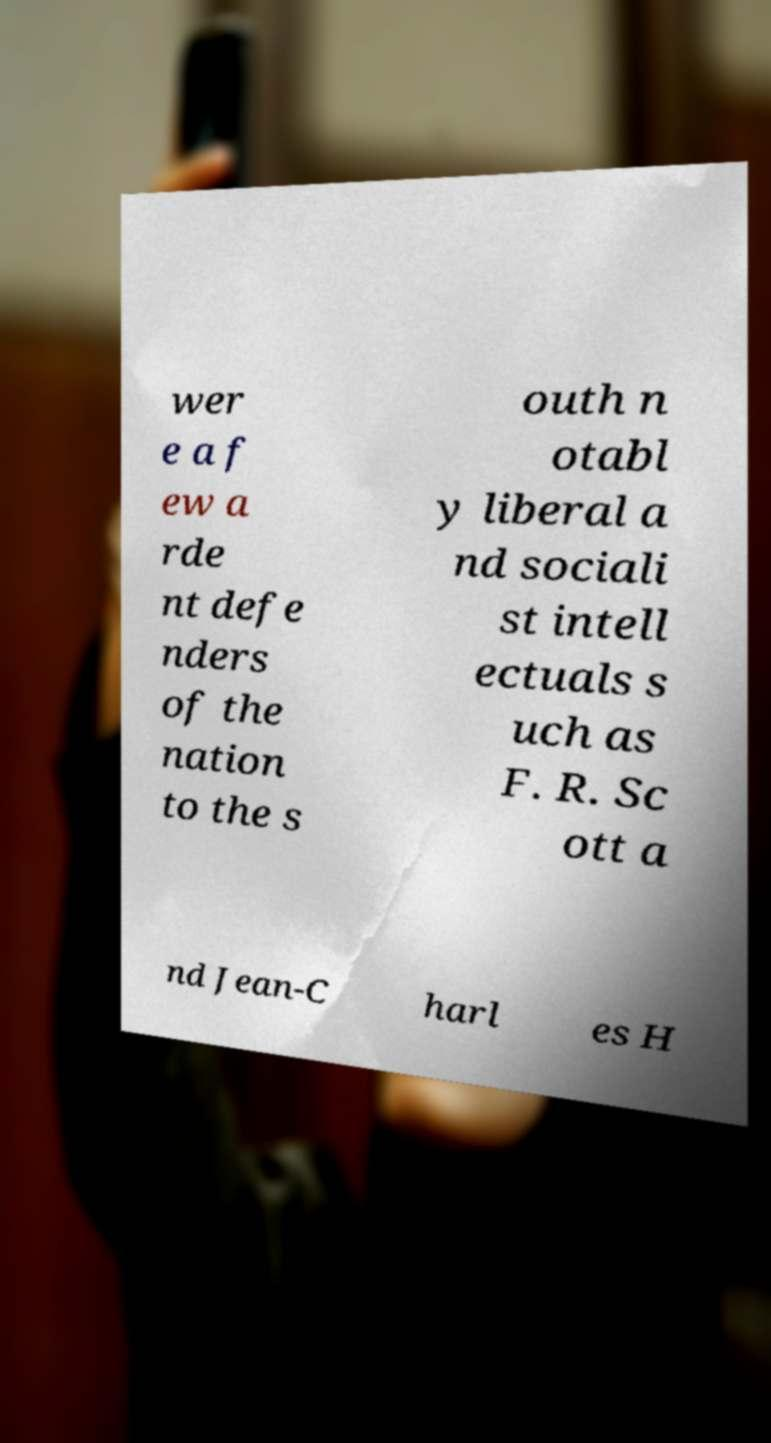What messages or text are displayed in this image? I need them in a readable, typed format. wer e a f ew a rde nt defe nders of the nation to the s outh n otabl y liberal a nd sociali st intell ectuals s uch as F. R. Sc ott a nd Jean-C harl es H 